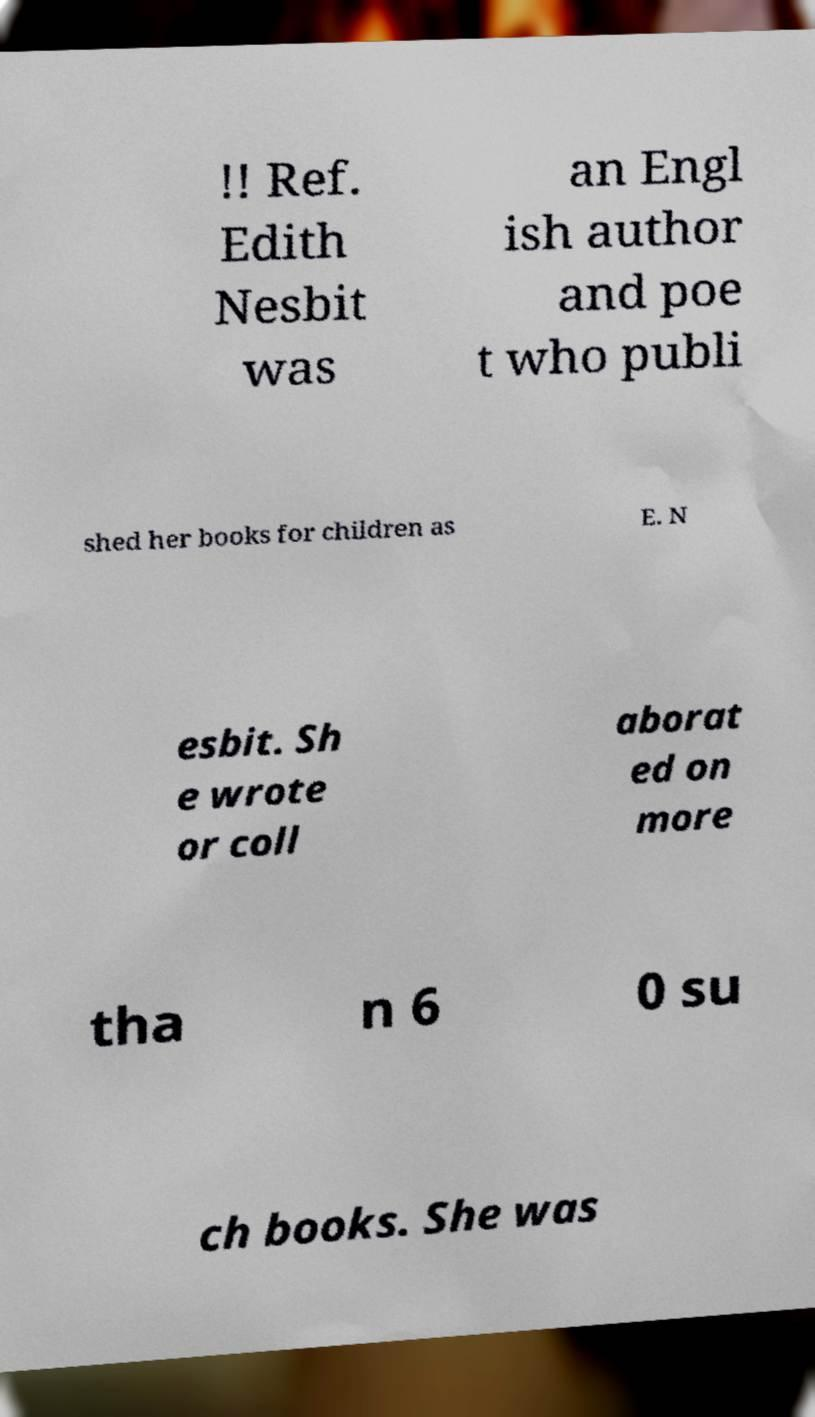For documentation purposes, I need the text within this image transcribed. Could you provide that? !! Ref. Edith Nesbit was an Engl ish author and poe t who publi shed her books for children as E. N esbit. Sh e wrote or coll aborat ed on more tha n 6 0 su ch books. She was 